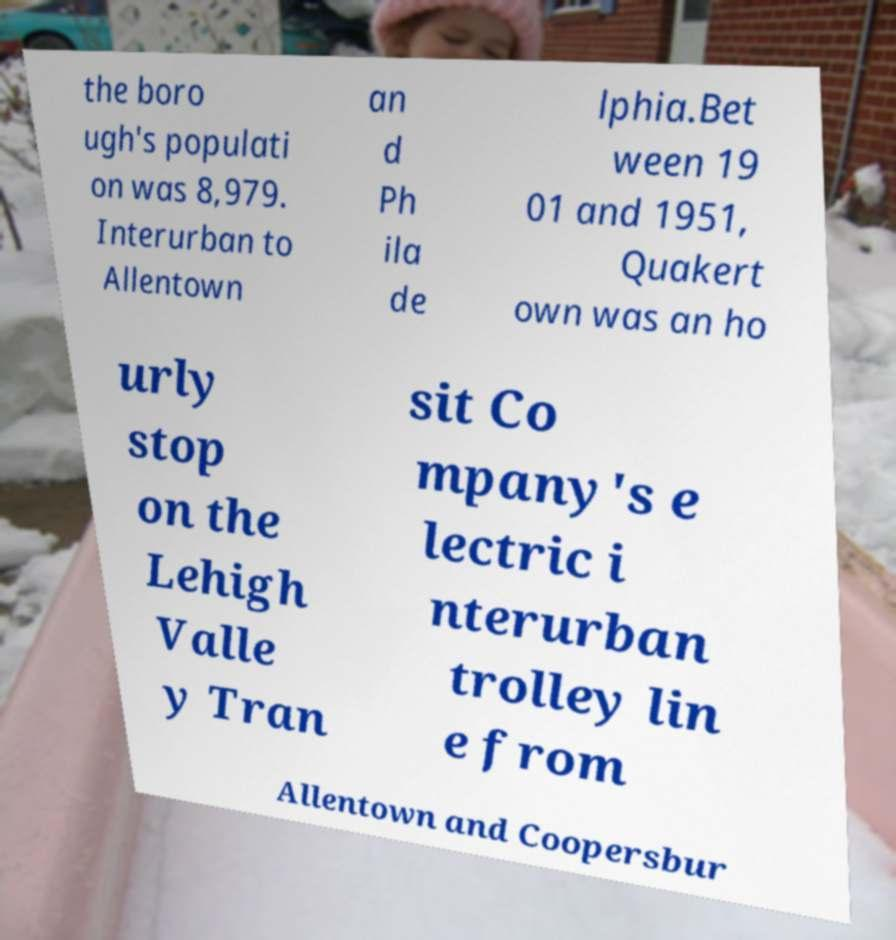For documentation purposes, I need the text within this image transcribed. Could you provide that? the boro ugh's populati on was 8,979. Interurban to Allentown an d Ph ila de lphia.Bet ween 19 01 and 1951, Quakert own was an ho urly stop on the Lehigh Valle y Tran sit Co mpany's e lectric i nterurban trolley lin e from Allentown and Coopersbur 